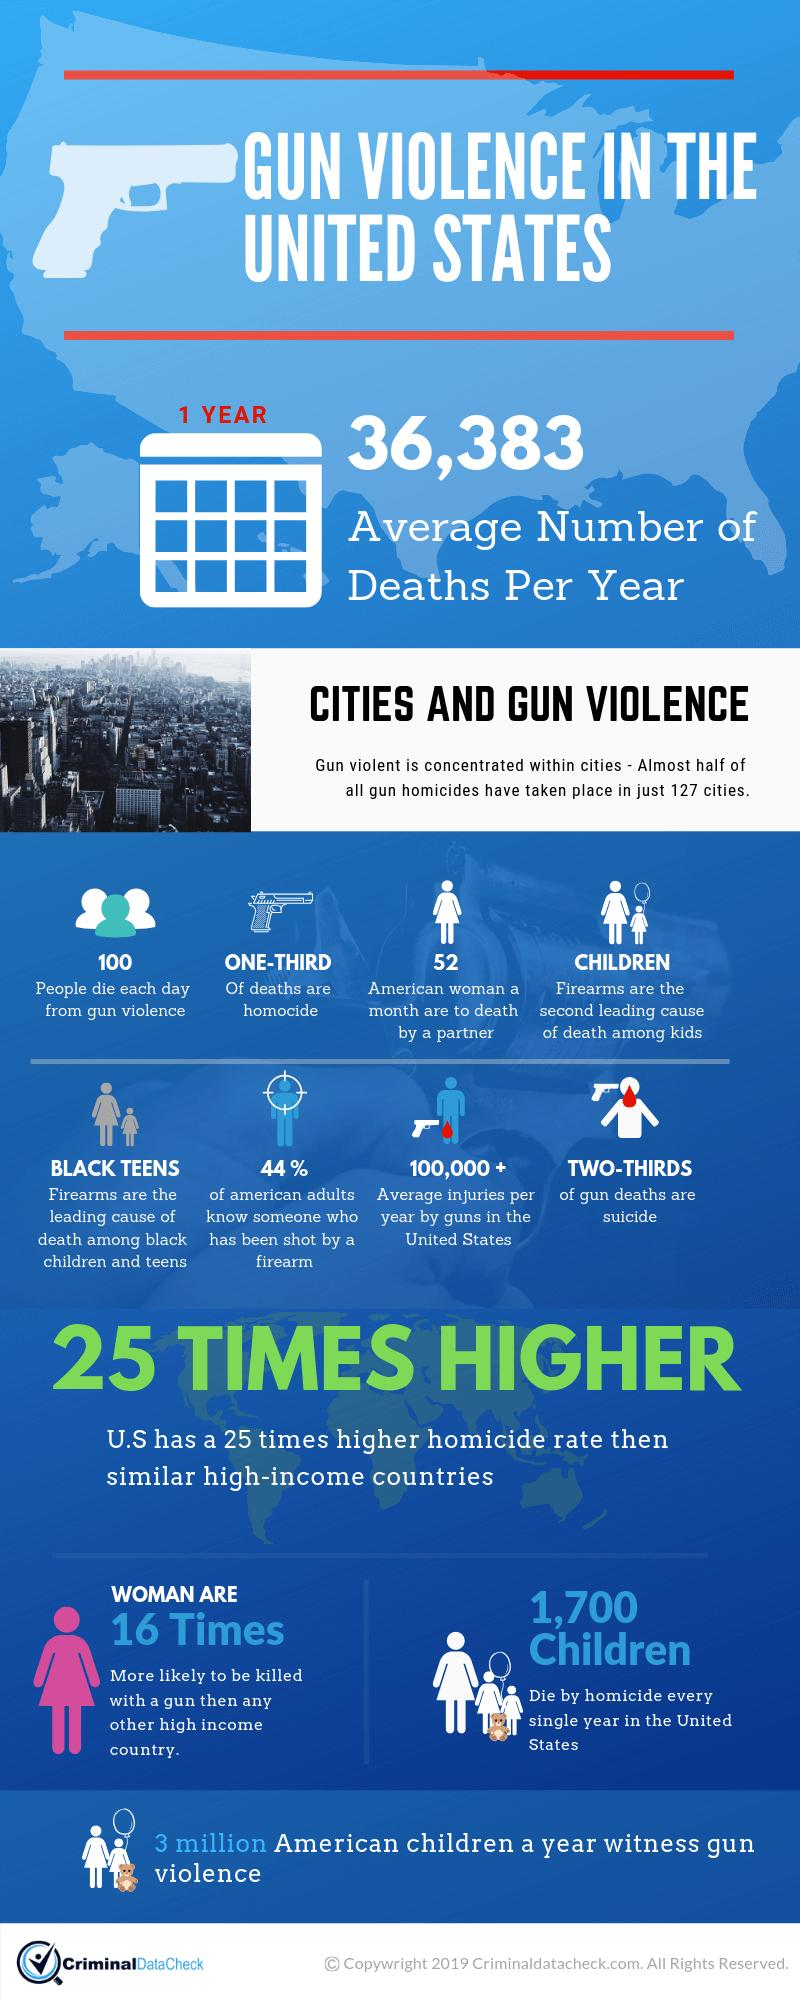Indicate a few pertinent items in this graphic. According to a recent survey, 56% of American adults do not know anyone who has been shot by a firearm. In the United States, an average of 52 women are killed by their partners each month. 